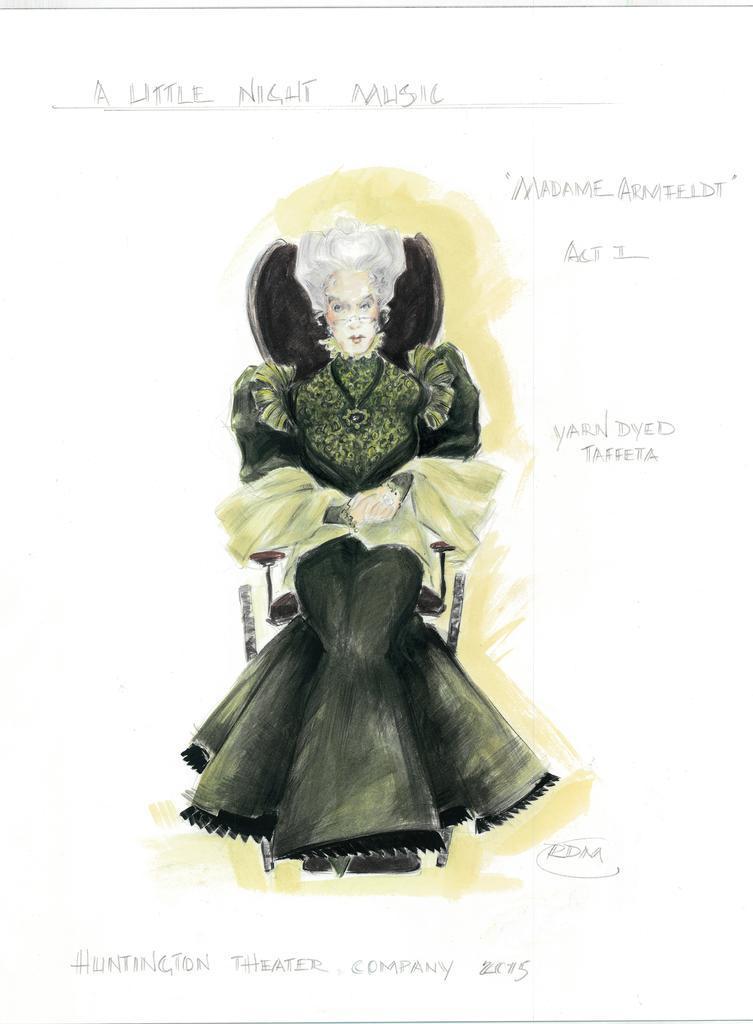Could you give a brief overview of what you see in this image? This might be a painting in this image in the center there is one woman sitting, and at the top and at the bottom there is some text. 